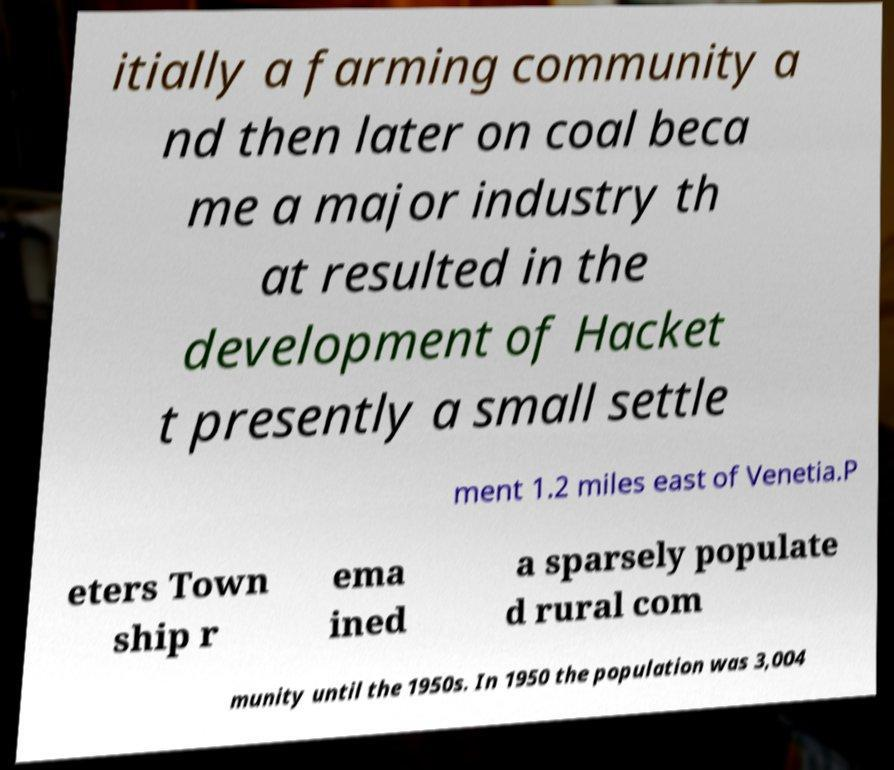Please read and relay the text visible in this image. What does it say? itially a farming community a nd then later on coal beca me a major industry th at resulted in the development of Hacket t presently a small settle ment 1.2 miles east of Venetia.P eters Town ship r ema ined a sparsely populate d rural com munity until the 1950s. In 1950 the population was 3,004 